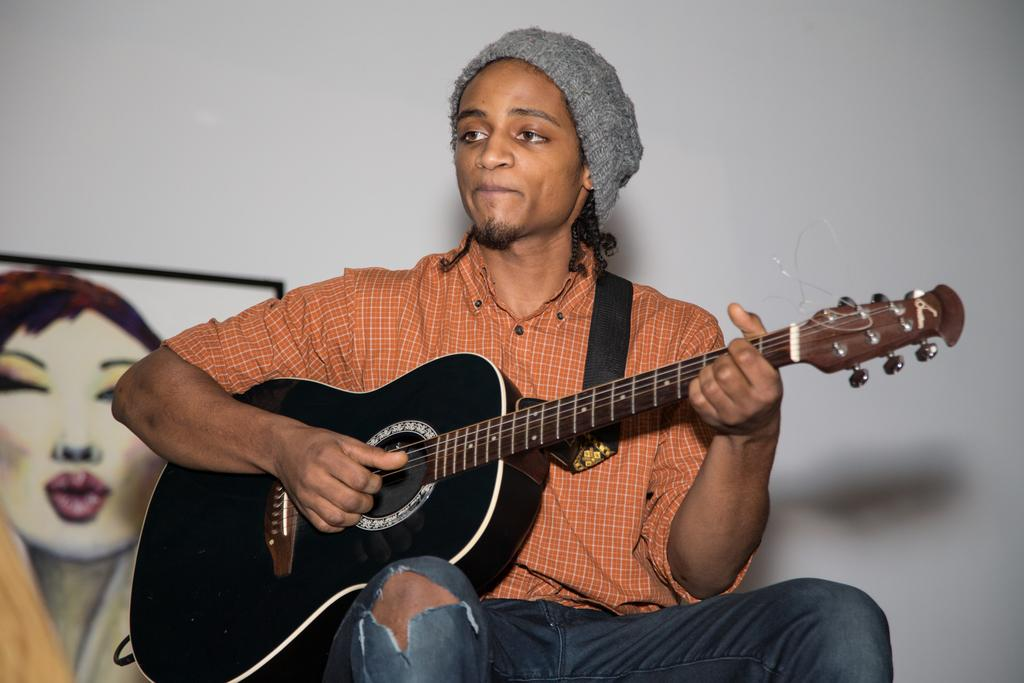What is the main subject of the image? There is a person in the image. What is the person doing in the image? The person is sitting on a chair and playing a guitar. What can be seen in the background of the image? The background of the image is white, and there is a wall painting. Where was the image taken? The image was taken inside a room. Can you see any houses or rivers in the image? No, there are no houses or rivers visible in the image. What type of copper object is present in the image? There is no copper object present in the image. 